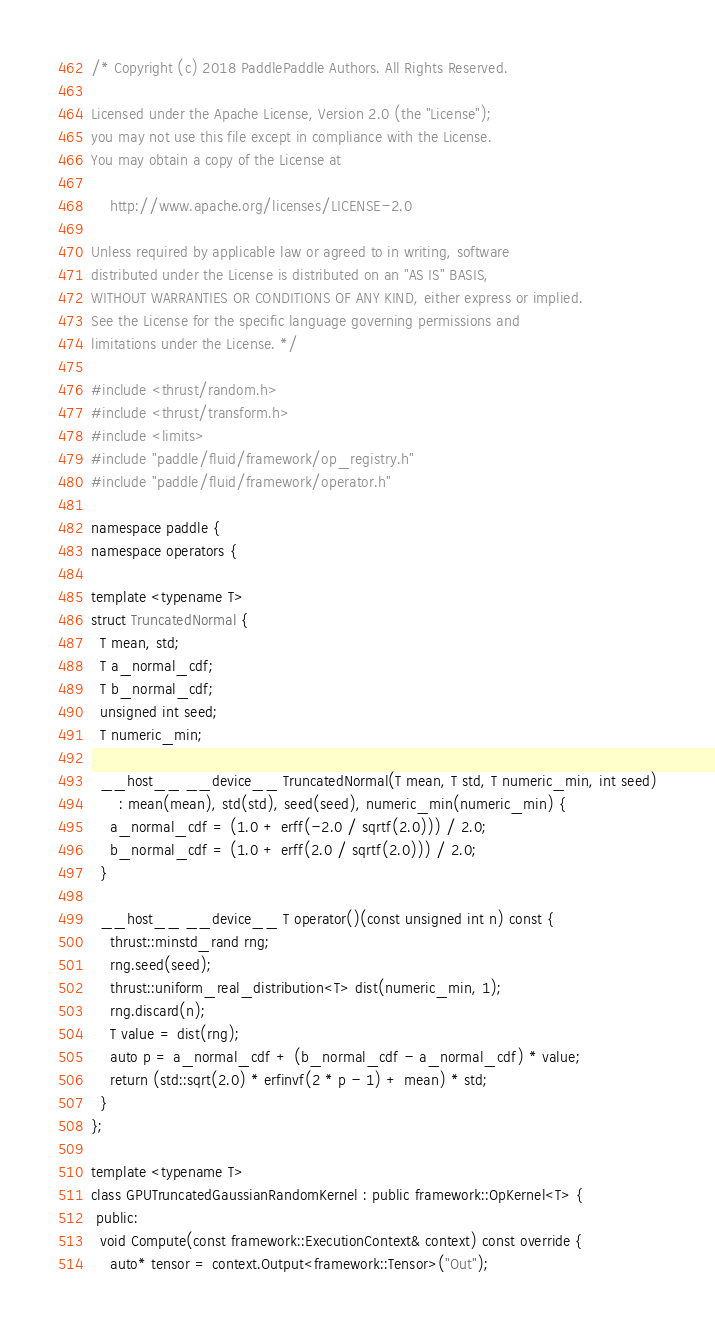Convert code to text. <code><loc_0><loc_0><loc_500><loc_500><_Cuda_>/* Copyright (c) 2018 PaddlePaddle Authors. All Rights Reserved.

Licensed under the Apache License, Version 2.0 (the "License");
you may not use this file except in compliance with the License.
You may obtain a copy of the License at

    http://www.apache.org/licenses/LICENSE-2.0

Unless required by applicable law or agreed to in writing, software
distributed under the License is distributed on an "AS IS" BASIS,
WITHOUT WARRANTIES OR CONDITIONS OF ANY KIND, either express or implied.
See the License for the specific language governing permissions and
limitations under the License. */

#include <thrust/random.h>
#include <thrust/transform.h>
#include <limits>
#include "paddle/fluid/framework/op_registry.h"
#include "paddle/fluid/framework/operator.h"

namespace paddle {
namespace operators {

template <typename T>
struct TruncatedNormal {
  T mean, std;
  T a_normal_cdf;
  T b_normal_cdf;
  unsigned int seed;
  T numeric_min;

  __host__ __device__ TruncatedNormal(T mean, T std, T numeric_min, int seed)
      : mean(mean), std(std), seed(seed), numeric_min(numeric_min) {
    a_normal_cdf = (1.0 + erff(-2.0 / sqrtf(2.0))) / 2.0;
    b_normal_cdf = (1.0 + erff(2.0 / sqrtf(2.0))) / 2.0;
  }

  __host__ __device__ T operator()(const unsigned int n) const {
    thrust::minstd_rand rng;
    rng.seed(seed);
    thrust::uniform_real_distribution<T> dist(numeric_min, 1);
    rng.discard(n);
    T value = dist(rng);
    auto p = a_normal_cdf + (b_normal_cdf - a_normal_cdf) * value;
    return (std::sqrt(2.0) * erfinvf(2 * p - 1) + mean) * std;
  }
};

template <typename T>
class GPUTruncatedGaussianRandomKernel : public framework::OpKernel<T> {
 public:
  void Compute(const framework::ExecutionContext& context) const override {
    auto* tensor = context.Output<framework::Tensor>("Out");</code> 